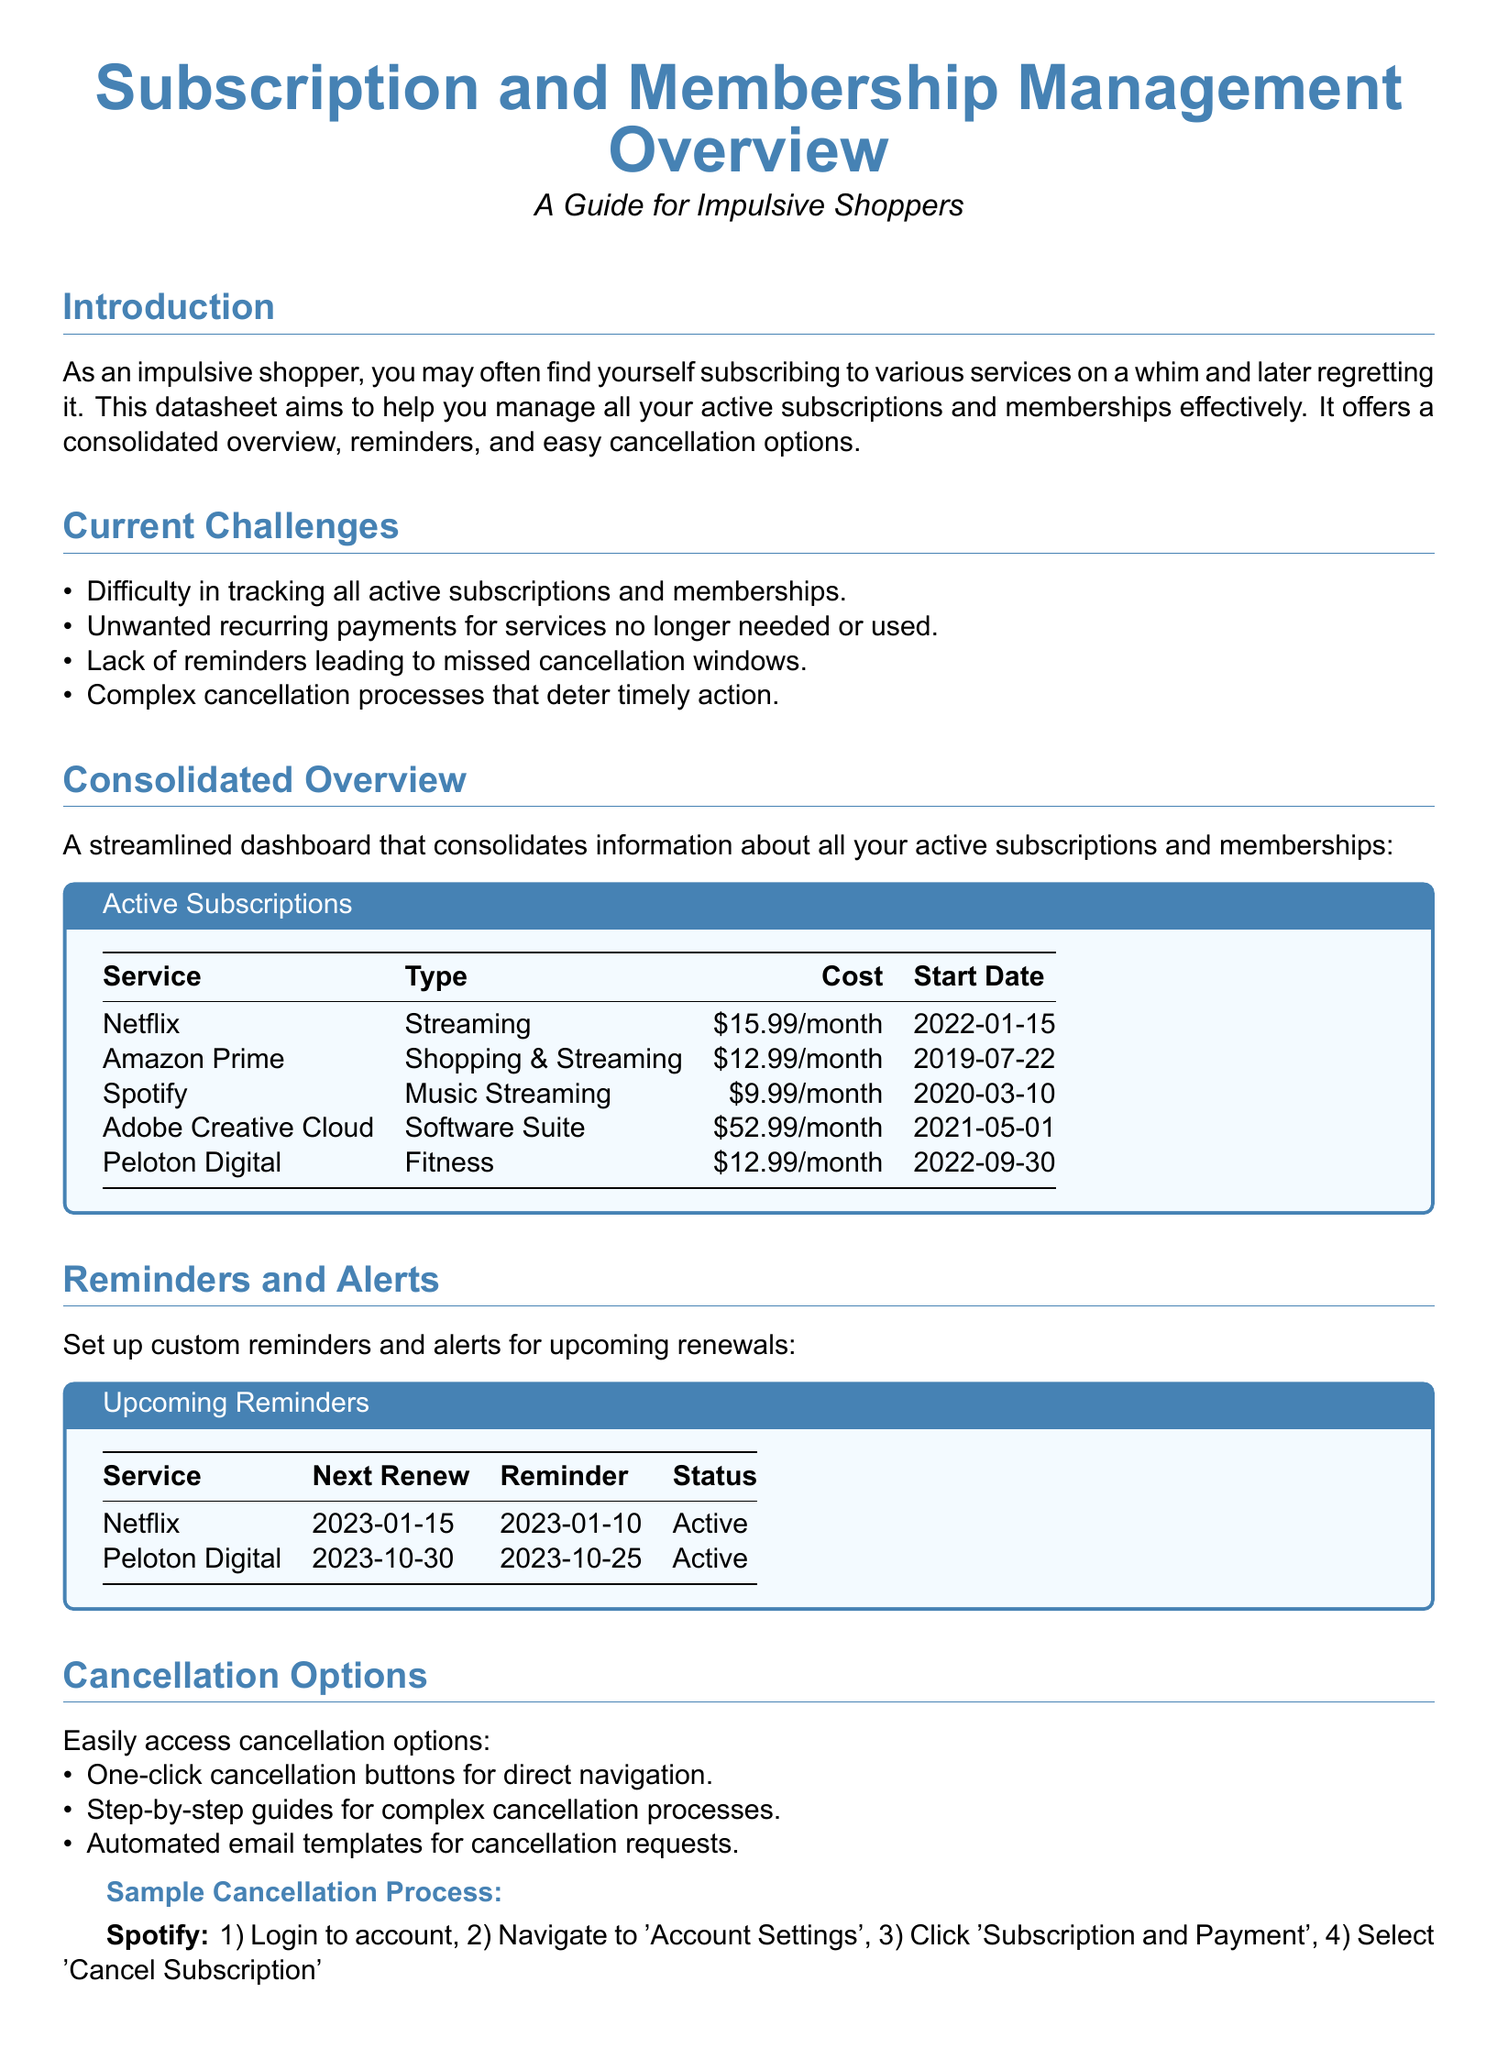What is the cost of Netflix? The cost of Netflix is listed in the "Consolidated Overview" section of the document as $15.99/month.
Answer: $15.99/month When did Amazon Prime start? The start date for Amazon Prime is provided in the "Consolidated Overview" section, which states it began on 2019-07-22.
Answer: 2019-07-22 What is the type of Adobe Creative Cloud? The type for Adobe Creative Cloud is categorized as "Software Suite" in the document.
Answer: Software Suite How many services have upcoming reminders? The document states that there are two services listed in the "Upcoming Reminders" section.
Answer: 2 What is the status of Peloton Digital? The status of Peloton Digital is indicated in the "Upcoming Reminders" section, shown as "Active".
Answer: Active What reminder is set for Netflix? The reminder set for Netflix is found under the "Upcoming Reminders", which is 2023-01-10.
Answer: 2023-01-10 What is the first step in the cancellation process for Spotify? The first step in the cancellation process for Spotify is mentioned in the "Sample Cancellation Process" section as Logging in to the account.
Answer: Login to account What is a suggested best practice for evaluating subscriptions? The document suggests that a good practice is to evaluate the necessity and value of each subscription periodically.
Answer: Evaluate necessity and value How can users access cancellation options? Users can access cancellation options easily through one-click cancellation buttons, as listed in the "Cancellation Options" section.
Answer: One-click cancellation buttons 